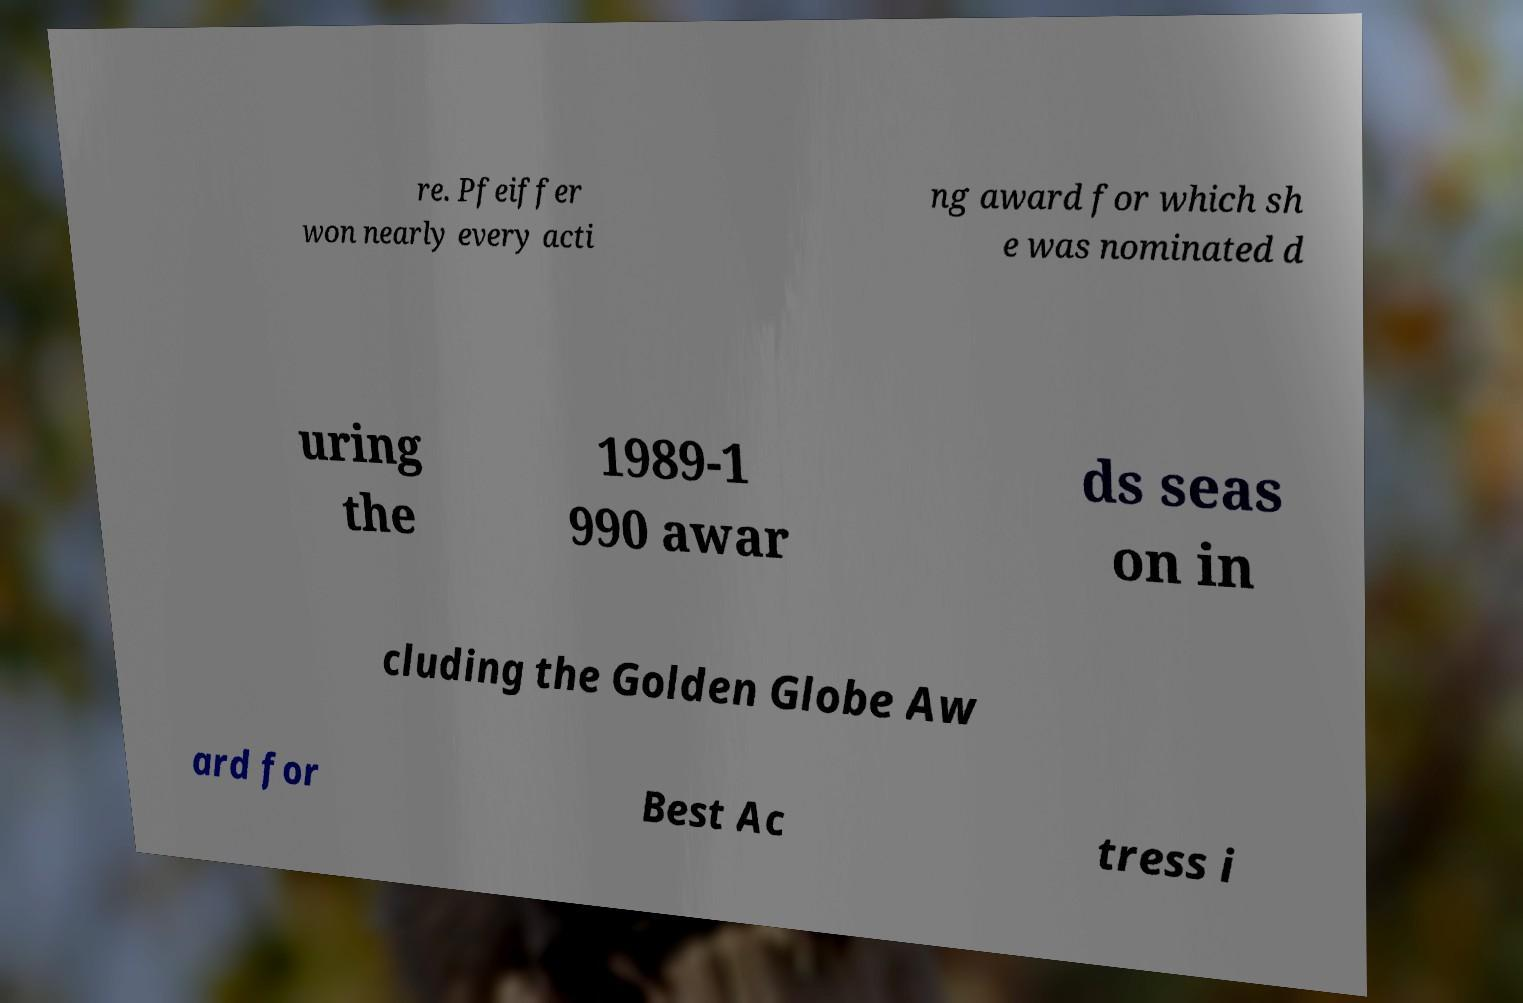For documentation purposes, I need the text within this image transcribed. Could you provide that? re. Pfeiffer won nearly every acti ng award for which sh e was nominated d uring the 1989-1 990 awar ds seas on in cluding the Golden Globe Aw ard for Best Ac tress i 